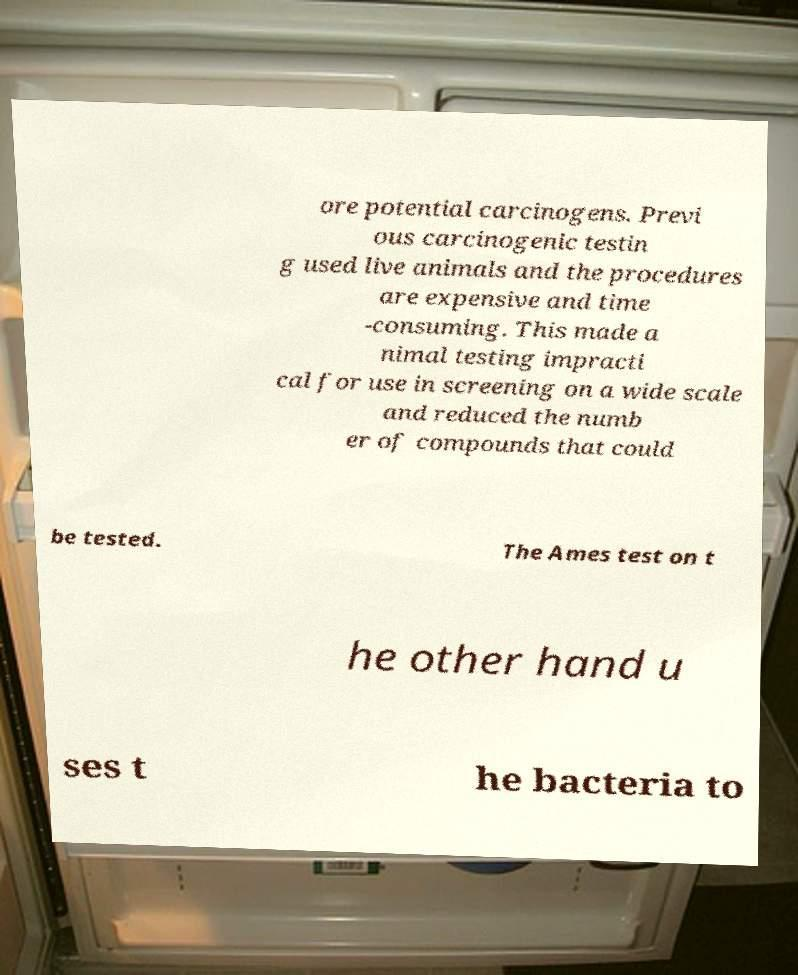I need the written content from this picture converted into text. Can you do that? ore potential carcinogens. Previ ous carcinogenic testin g used live animals and the procedures are expensive and time -consuming. This made a nimal testing impracti cal for use in screening on a wide scale and reduced the numb er of compounds that could be tested. The Ames test on t he other hand u ses t he bacteria to 